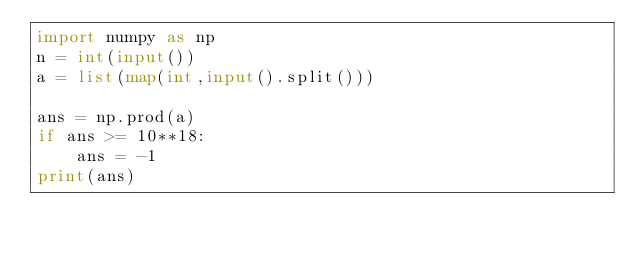<code> <loc_0><loc_0><loc_500><loc_500><_Python_>import numpy as np
n = int(input())
a = list(map(int,input().split()))

ans = np.prod(a)
if ans >= 10**18:
    ans = -1
print(ans)
</code> 